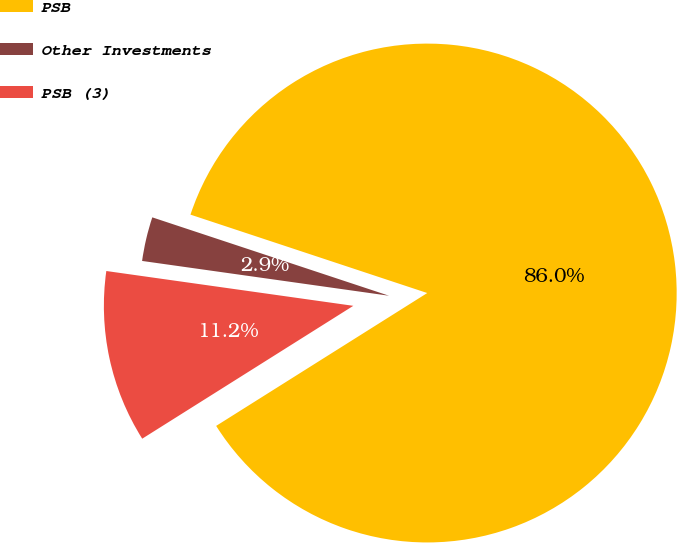Convert chart. <chart><loc_0><loc_0><loc_500><loc_500><pie_chart><fcel>PSB<fcel>Other Investments<fcel>PSB (3)<nl><fcel>85.97%<fcel>2.86%<fcel>11.17%<nl></chart> 